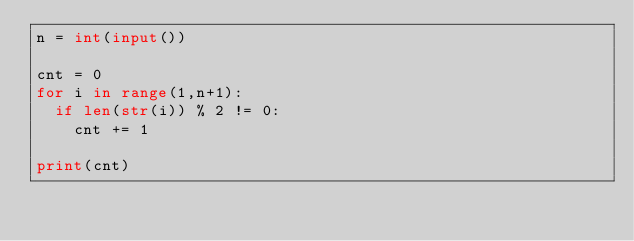Convert code to text. <code><loc_0><loc_0><loc_500><loc_500><_Python_>n = int(input())

cnt = 0
for i in range(1,n+1):
  if len(str(i)) % 2 != 0:
    cnt += 1

print(cnt)</code> 